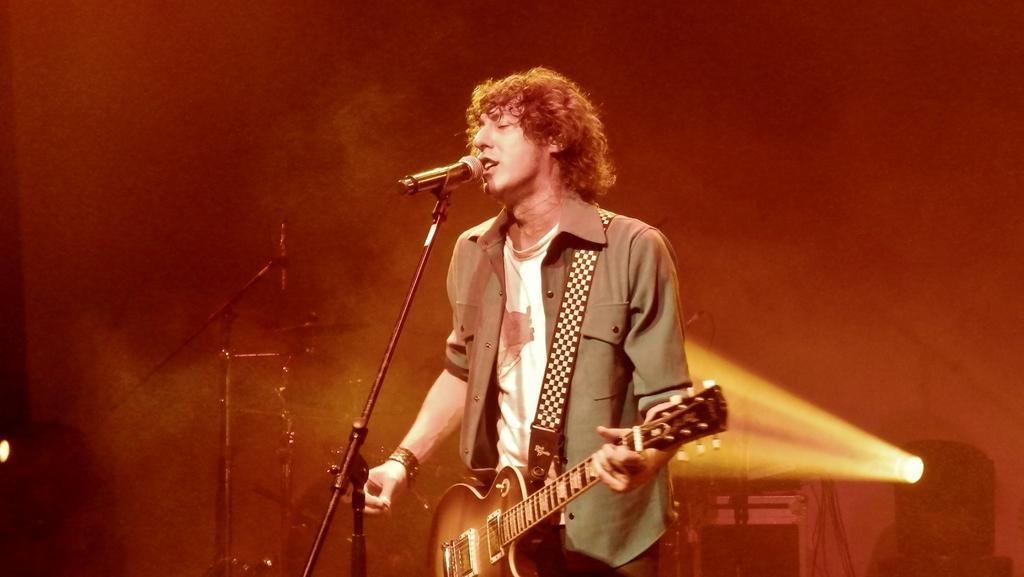What is the person in the image doing? The person is holding a guitar. What object is in front of the person? There is a microphone in front of the person. Can you describe anything in the background of the image? There is a light visible in the background of the image. How many chickens are on stage with the person in the image? There are no chickens present in the image. What level of expertise does the person have with the guitar in the image? The level of expertise of the person with the guitar cannot be determined from the image. 